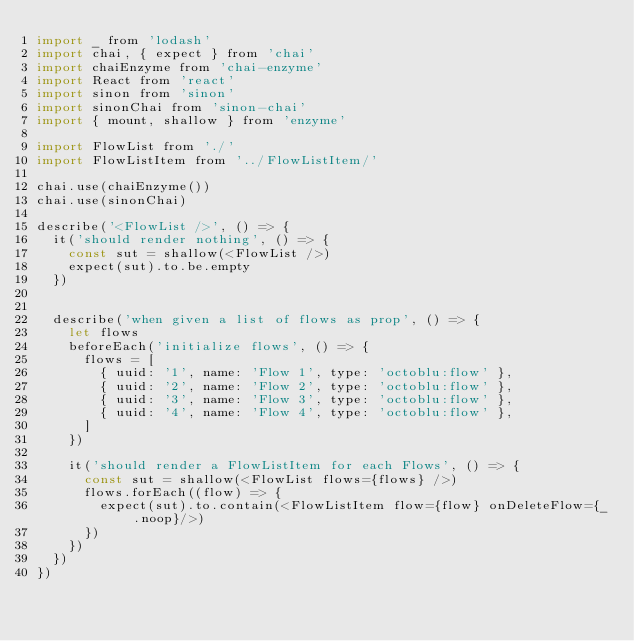Convert code to text. <code><loc_0><loc_0><loc_500><loc_500><_JavaScript_>import _ from 'lodash'
import chai, { expect } from 'chai'
import chaiEnzyme from 'chai-enzyme'
import React from 'react'
import sinon from 'sinon'
import sinonChai from 'sinon-chai'
import { mount, shallow } from 'enzyme'

import FlowList from './'
import FlowListItem from '../FlowListItem/'

chai.use(chaiEnzyme())
chai.use(sinonChai)

describe('<FlowList />', () => {
  it('should render nothing', () => {
    const sut = shallow(<FlowList />)
    expect(sut).to.be.empty
  })


  describe('when given a list of flows as prop', () => {
    let flows
    beforeEach('initialize flows', () => {
      flows = [
        { uuid: '1', name: 'Flow 1', type: 'octoblu:flow' },
        { uuid: '2', name: 'Flow 2', type: 'octoblu:flow' },
        { uuid: '3', name: 'Flow 3', type: 'octoblu:flow' },
        { uuid: '4', name: 'Flow 4', type: 'octoblu:flow' },
      ]
    })

    it('should render a FlowListItem for each Flows', () => {
      const sut = shallow(<FlowList flows={flows} />)
      flows.forEach((flow) => {
        expect(sut).to.contain(<FlowListItem flow={flow} onDeleteFlow={_.noop}/>)
      })
    })
  })
})
</code> 